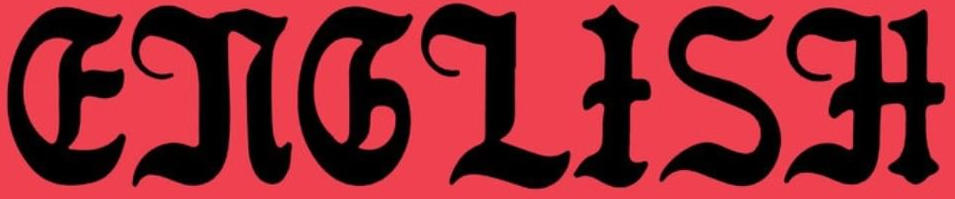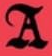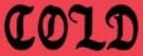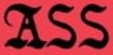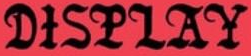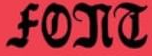Identify the words shown in these images in order, separated by a semicolon. ENGLISH; A; COLD; ASS; DISPLAY; FONT 